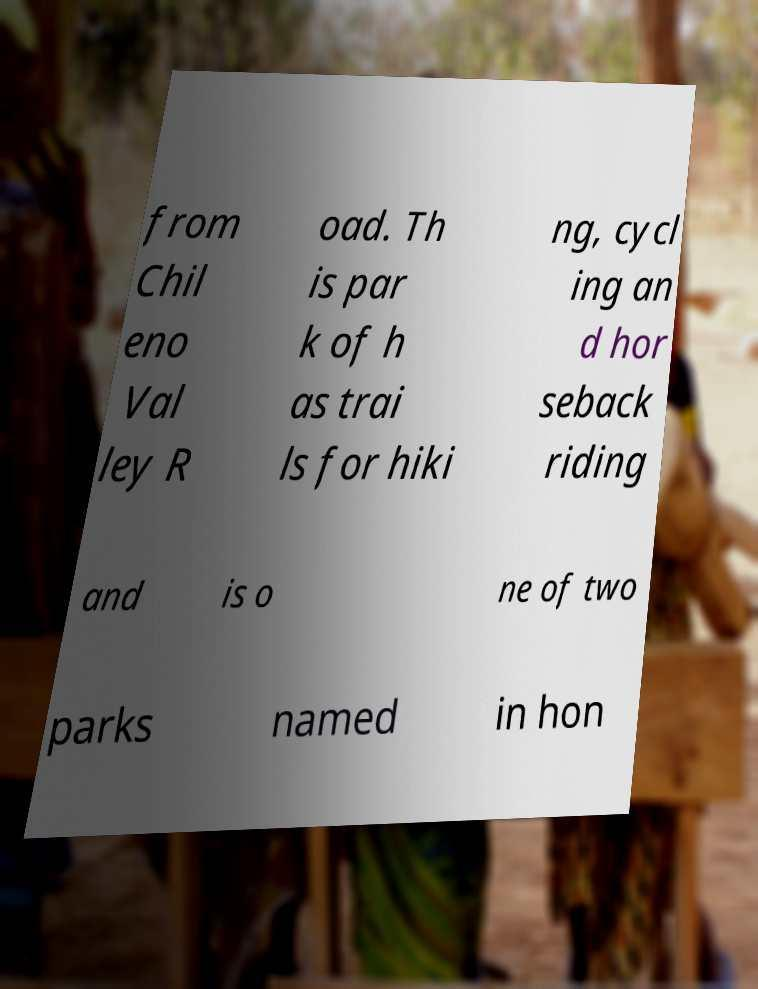What messages or text are displayed in this image? I need them in a readable, typed format. from Chil eno Val ley R oad. Th is par k of h as trai ls for hiki ng, cycl ing an d hor seback riding and is o ne of two parks named in hon 